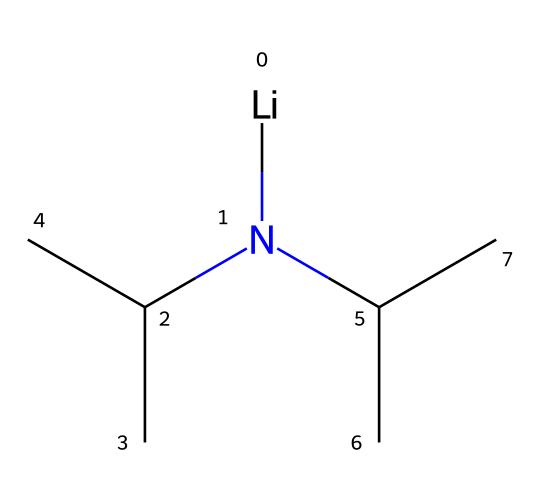How many carbon atoms are in lithium diisopropylamide? By looking at the SMILES representation, we can identify each carbon atom represented in the structure. The "C" and the "C(C)" indicate that there are a total of 6 carbon atoms in the structure, each contributing to the diisopropyl groups.
Answer: 6 What is the functional group present in lithium diisopropylamide? The presence of the nitrogen atom (N) associated with carbon groups and not involved in any double bonds indicates that this is an amine functional group, specifically a secondary amine due to two carbon groups attached to nitrogen.
Answer: amine How many isopropyl groups are present in lithium diisopropylamide? The "C(C)" notation indicates branching associated with isopropyl groups. Each "C(C)" represents one isopropyl group, and since there are two such segments, we conclude that there are two isopropyl groups.
Answer: 2 Is lithium diisopropylamide a strong or weak base? Given that diisopropylamide groups are known for their basic properties in organic chemistry, and the presence of lithium implies it is a strong base commonly used to deprotonate acids, it is classified as a strong base.
Answer: strong base What element serves as the central cation in lithium diisopropylamide? The "Li" at the beginning of the SMILES clearly denotes lithium as the central cation in this compound.
Answer: lithium What type of organic compound does lithium diisopropylamide belong to? This compound is formed from an amine and is often classified under superbases due to its high reactivity and ability to deprotonate weak acids effectively. The presence of the lithium cation along with the amine confirms this classification.
Answer: superbase 